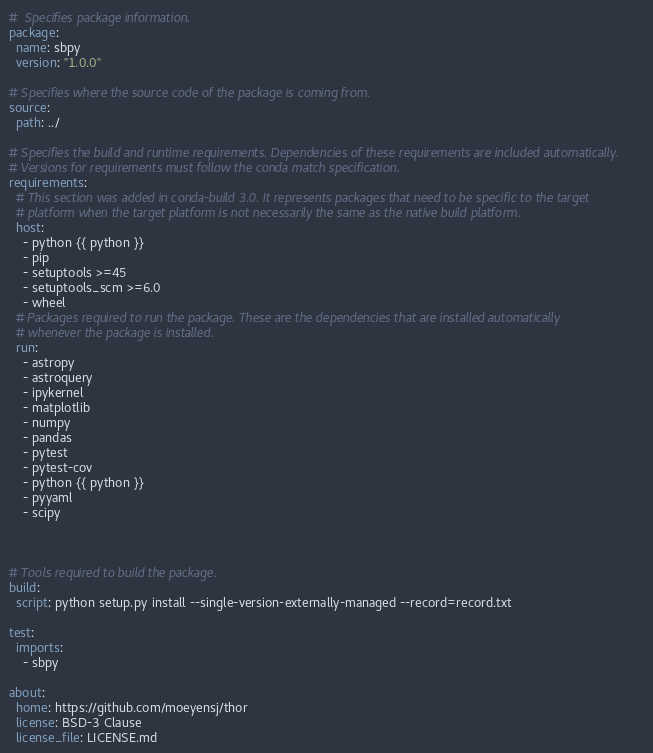Convert code to text. <code><loc_0><loc_0><loc_500><loc_500><_YAML_>#  Specifies package information.
package:
  name: sbpy
  version: "1.0.0"

# Specifies where the source code of the package is coming from. 
source:
  path: ../

# Specifies the build and runtime requirements. Dependencies of these requirements are included automatically.
# Versions for requirements must follow the conda match specification.
requirements:
  # This section was added in conda-build 3.0. It represents packages that need to be specific to the target 
  # platform when the target platform is not necessarily the same as the native build platform.
  host:
    - python {{ python }}
    - pip
    - setuptools >=45
    - setuptools_scm >=6.0
    - wheel
  # Packages required to run the package. These are the dependencies that are installed automatically 
  # whenever the package is installed. 
  run:
    - astropy
    - astroquery
    - ipykernel
    - matplotlib
    - numpy
    - pandas
    - pytest
    - pytest-cov
    - python {{ python }}
    - pyyaml
    - scipy
    
    

# Tools required to build the package. 
build:
  script: python setup.py install --single-version-externally-managed --record=record.txt

test:
  imports:
    - sbpy

about:
  home: https://github.com/moeyensj/thor
  license: BSD-3 Clause
  license_file: LICENSE.md</code> 